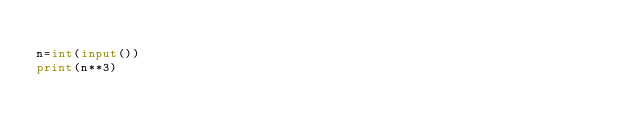Convert code to text. <code><loc_0><loc_0><loc_500><loc_500><_Python_>
n=int(input())
print(n**3)</code> 